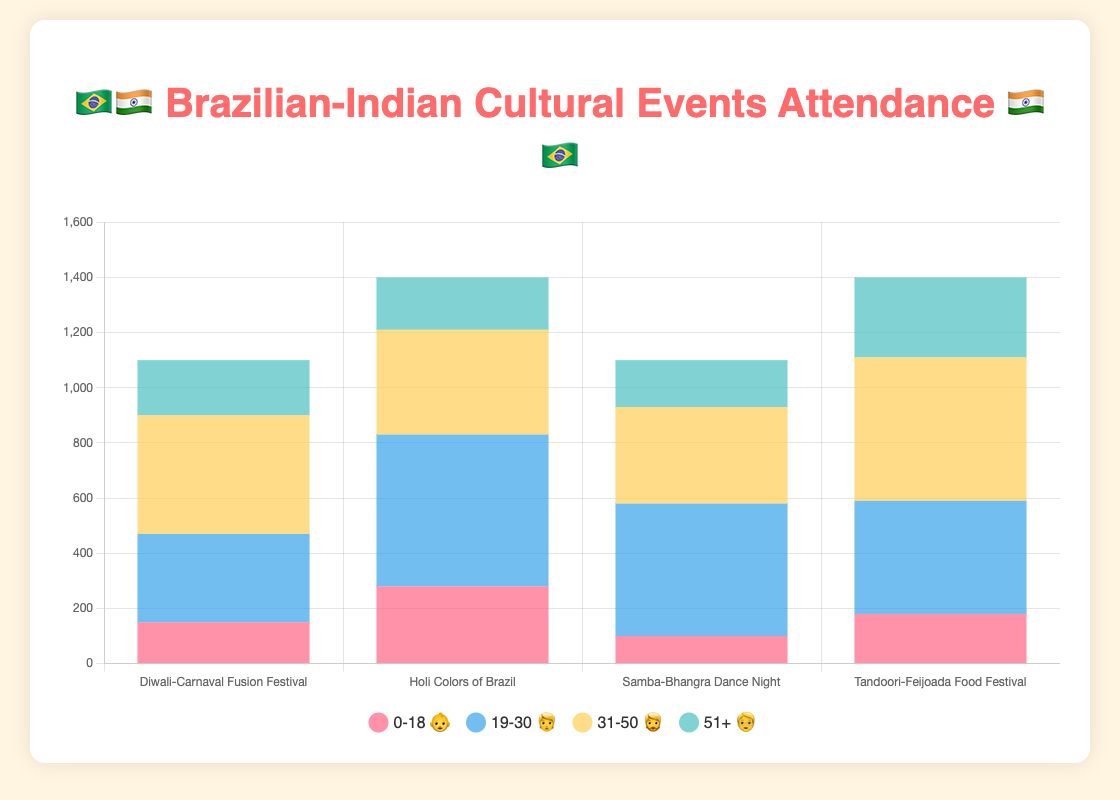Which event has the highest attendance in the 51+ age group? Look for the tallest bar corresponding to the 51+ (🧓) age group. The "Tandoori-Feijoada Food Festival" has the highest attendance at 290.
Answer: Tandoori-Feijoada Food Festival What is the total attendance of the 0-18 age group across all events? Sum the attendance numbers for the 0-18 (👶) age group from each event: 150 + 280 + 100 + 180 = 710.
Answer: 710 Which age group has the lowest attendance at the Samba-Bhangra Dance Night? Examine the heights of the bars for the Samba-Bhangra Dance Night. The 0-18 (👶) age group has the lowest attendance at 100.
Answer: 0-18 (👶) Compare the attendance of the 31-50 age group at the Diwali-Carnaval Fusion Festival and the Holi Colors of Brazil. Which is higher? Check the attendance numbers for the 31-50 (🧔) age group. The Diwali-Carnaval Fusion Festival has 430, while the Holi Colors of Brazil has 380. 430 is higher than 380.
Answer: Diwali-Carnaval Fusion Festival What is the average attendance for the 19-30 age group across all events? Find the attendance for the 19-30 (🧑) age group: 320 + 550 + 480 + 410. The sum is 1760, and there are four events, so the average is 1760 / 4 = 440.
Answer: 440 What is the difference in attendance between the youngest and oldest age groups at the Tandoori-Feijoada Food Festival? The attendance for the 0-18 (👶) age group is 180, and for the 51+ (🧓) age group, it is 290. The difference is 290 - 180 = 110.
Answer: 110 Which age group consistently has the highest attendance across all events? Compare the attendance numbers for each age group across all events. The 31-50 (🧔) age group has the highest or one of the highest attendance numbers for each event: 430, 380, 350, 520.
Answer: 31-50 (🧔) What percentage of total attendance does the 19-30 age group contribute to the Holi Colors of Brazil event? Total attendance for all age groups at this event is 280 + 550 + 380 + 190 = 1400. The 19-30 (🧑) age group attendance is 550. The percentage is (550 / 1400) * 100 ≈ 39.29%.
Answer: 39.29% 